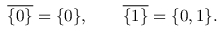Convert formula to latex. <formula><loc_0><loc_0><loc_500><loc_500>{ \overline { { \{ 0 \} } } } = \{ 0 \} , \quad { \overline { { \{ 1 \} } } } = \{ 0 , 1 \} .</formula> 